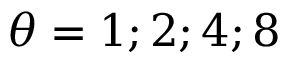Convert formula to latex. <formula><loc_0><loc_0><loc_500><loc_500>\theta = 1 ; 2 ; 4 ; 8</formula> 